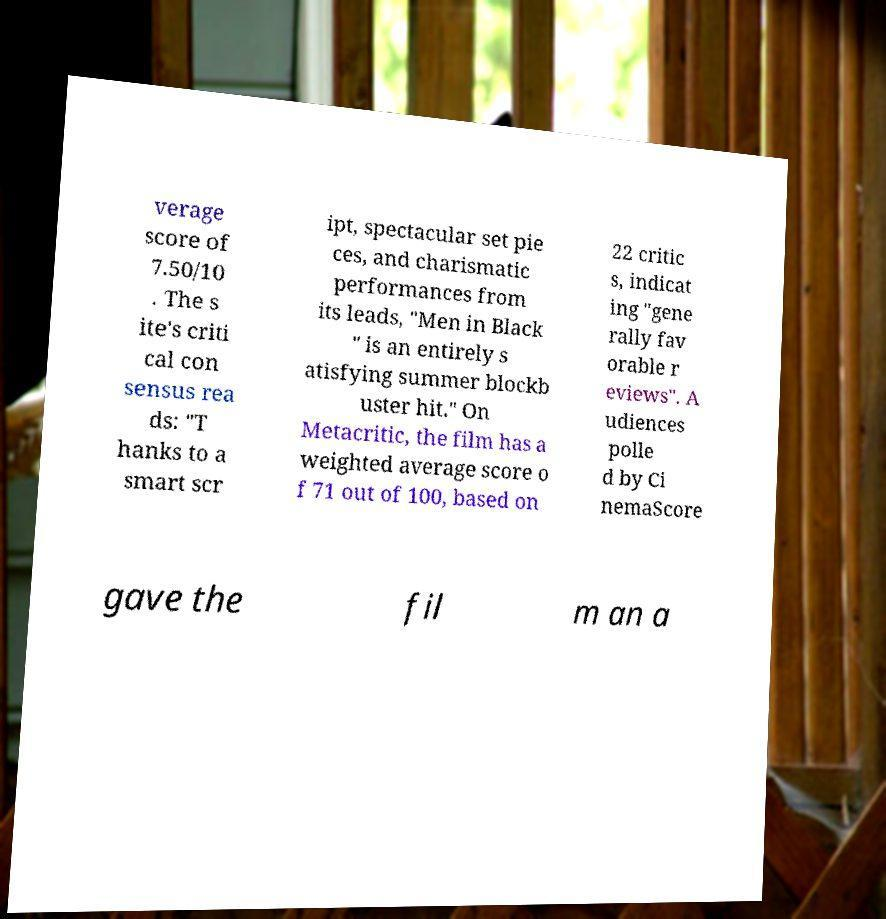I need the written content from this picture converted into text. Can you do that? verage score of 7.50/10 . The s ite's criti cal con sensus rea ds: "T hanks to a smart scr ipt, spectacular set pie ces, and charismatic performances from its leads, "Men in Black " is an entirely s atisfying summer blockb uster hit." On Metacritic, the film has a weighted average score o f 71 out of 100, based on 22 critic s, indicat ing "gene rally fav orable r eviews". A udiences polle d by Ci nemaScore gave the fil m an a 